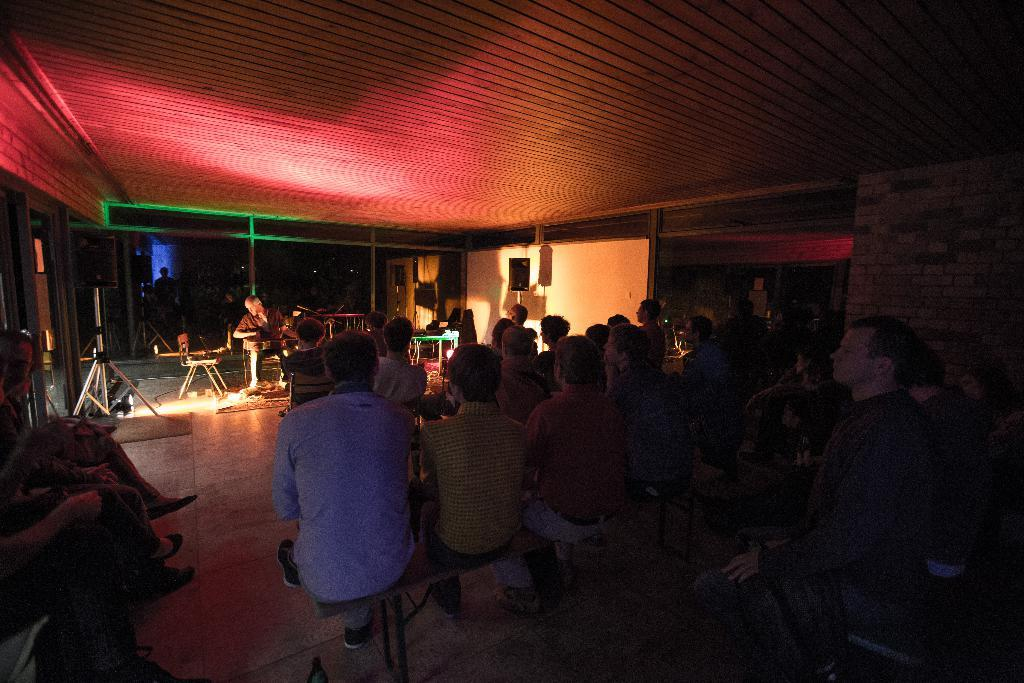What are the people in the hall doing? The people in the hall are listening to music. Who is playing the music in the image? There is a man sitting and playing the guitar in the image. What can be observed about the ceiling in the hall? There is a wooden ceiling in the image. What silver object is being used to create a special effect in the image? There is no silver object or special effect present in the image. 